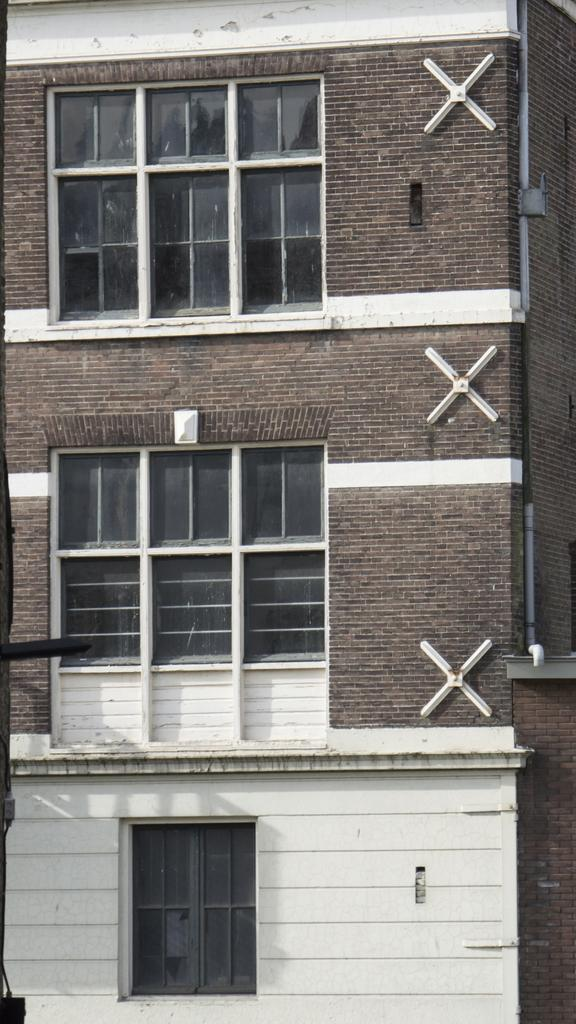What structure is present in the image? There is a building in the image. What features can be observed on the building? The building has windows and pipes. What type of wood is used to construct the building in the image? There is no information about the type of wood used in the construction of the building in the image. Can you see any boats or ships in the harbor near the building in the image? There is no harbor or any boats or ships visible in the image. What type of fowl can be seen perched on the building in the image? There are no fowl visible on the building in the image. 